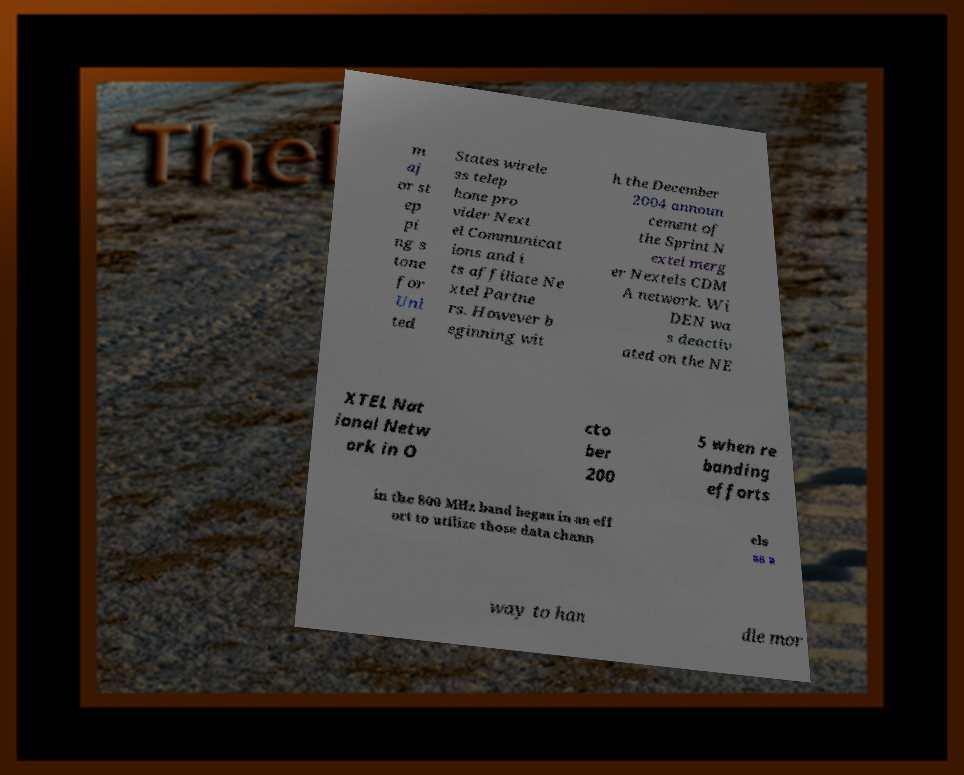What messages or text are displayed in this image? I need them in a readable, typed format. m aj or st ep pi ng s tone for Uni ted States wirele ss telep hone pro vider Next el Communicat ions and i ts affiliate Ne xtel Partne rs. However b eginning wit h the December 2004 announ cement of the Sprint N extel merg er Nextels CDM A network. Wi DEN wa s deactiv ated on the NE XTEL Nat ional Netw ork in O cto ber 200 5 when re banding efforts in the 800 MHz band began in an eff ort to utilize those data chann els as a way to han dle mor 